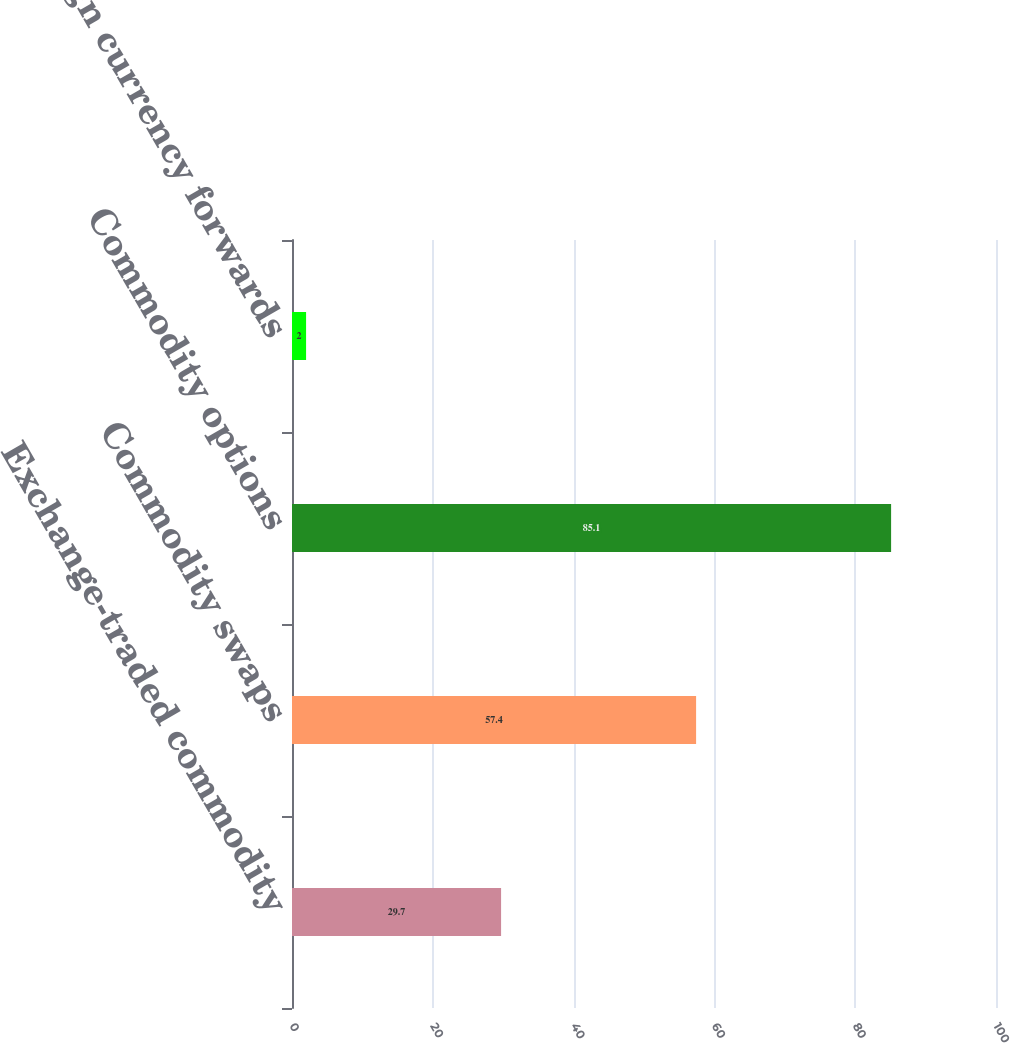Convert chart. <chart><loc_0><loc_0><loc_500><loc_500><bar_chart><fcel>Exchange-traded commodity<fcel>Commodity swaps<fcel>Commodity options<fcel>Foreign currency forwards<nl><fcel>29.7<fcel>57.4<fcel>85.1<fcel>2<nl></chart> 